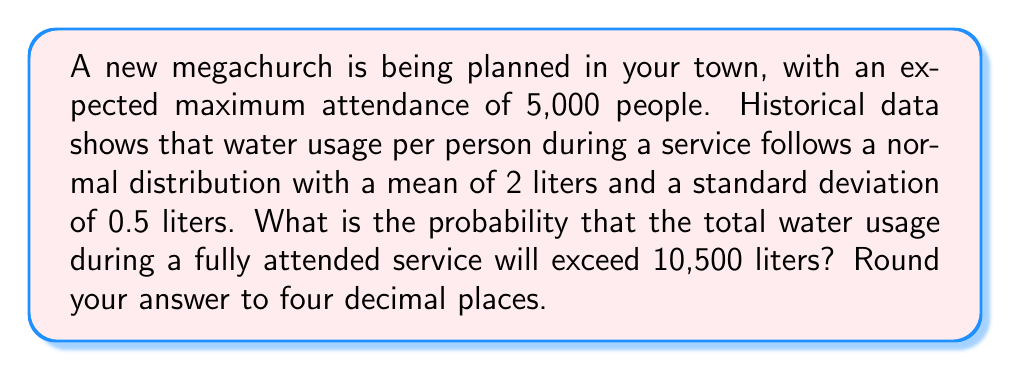Solve this math problem. Let's approach this step-by-step:

1) First, we need to calculate the mean and standard deviation of the total water usage:

   Mean: $\mu_{total} = 5000 \times 2 = 10000$ liters
   
   Standard deviation: $\sigma_{total} = \sqrt{5000} \times 0.5 = 35.36$ liters

   (We use $\sqrt{5000}$ because the standard deviation of a sum of independent normal variables is the square root of the sum of their variances)

2) We want to find $P(X > 10500)$ where $X$ is the total water usage.

3) We can standardize this to a z-score:

   $$z = \frac{X - \mu}{\sigma} = \frac{10500 - 10000}{35.36} = 14.14$$

4) We need to find $P(Z > 14.14)$ where $Z$ is a standard normal variable.

5) Using a standard normal table or calculator, we can find that:

   $P(Z < 14.14) \approx 1$

6) Therefore, $P(Z > 14.14) = 1 - P(Z < 14.14) \approx 0$

7) More precisely, using a more accurate calculation method:

   $P(Z > 14.14) \approx 1.3522 \times 10^{-45}$

8) Rounding to four decimal places: 0.0000
Answer: 0.0000 